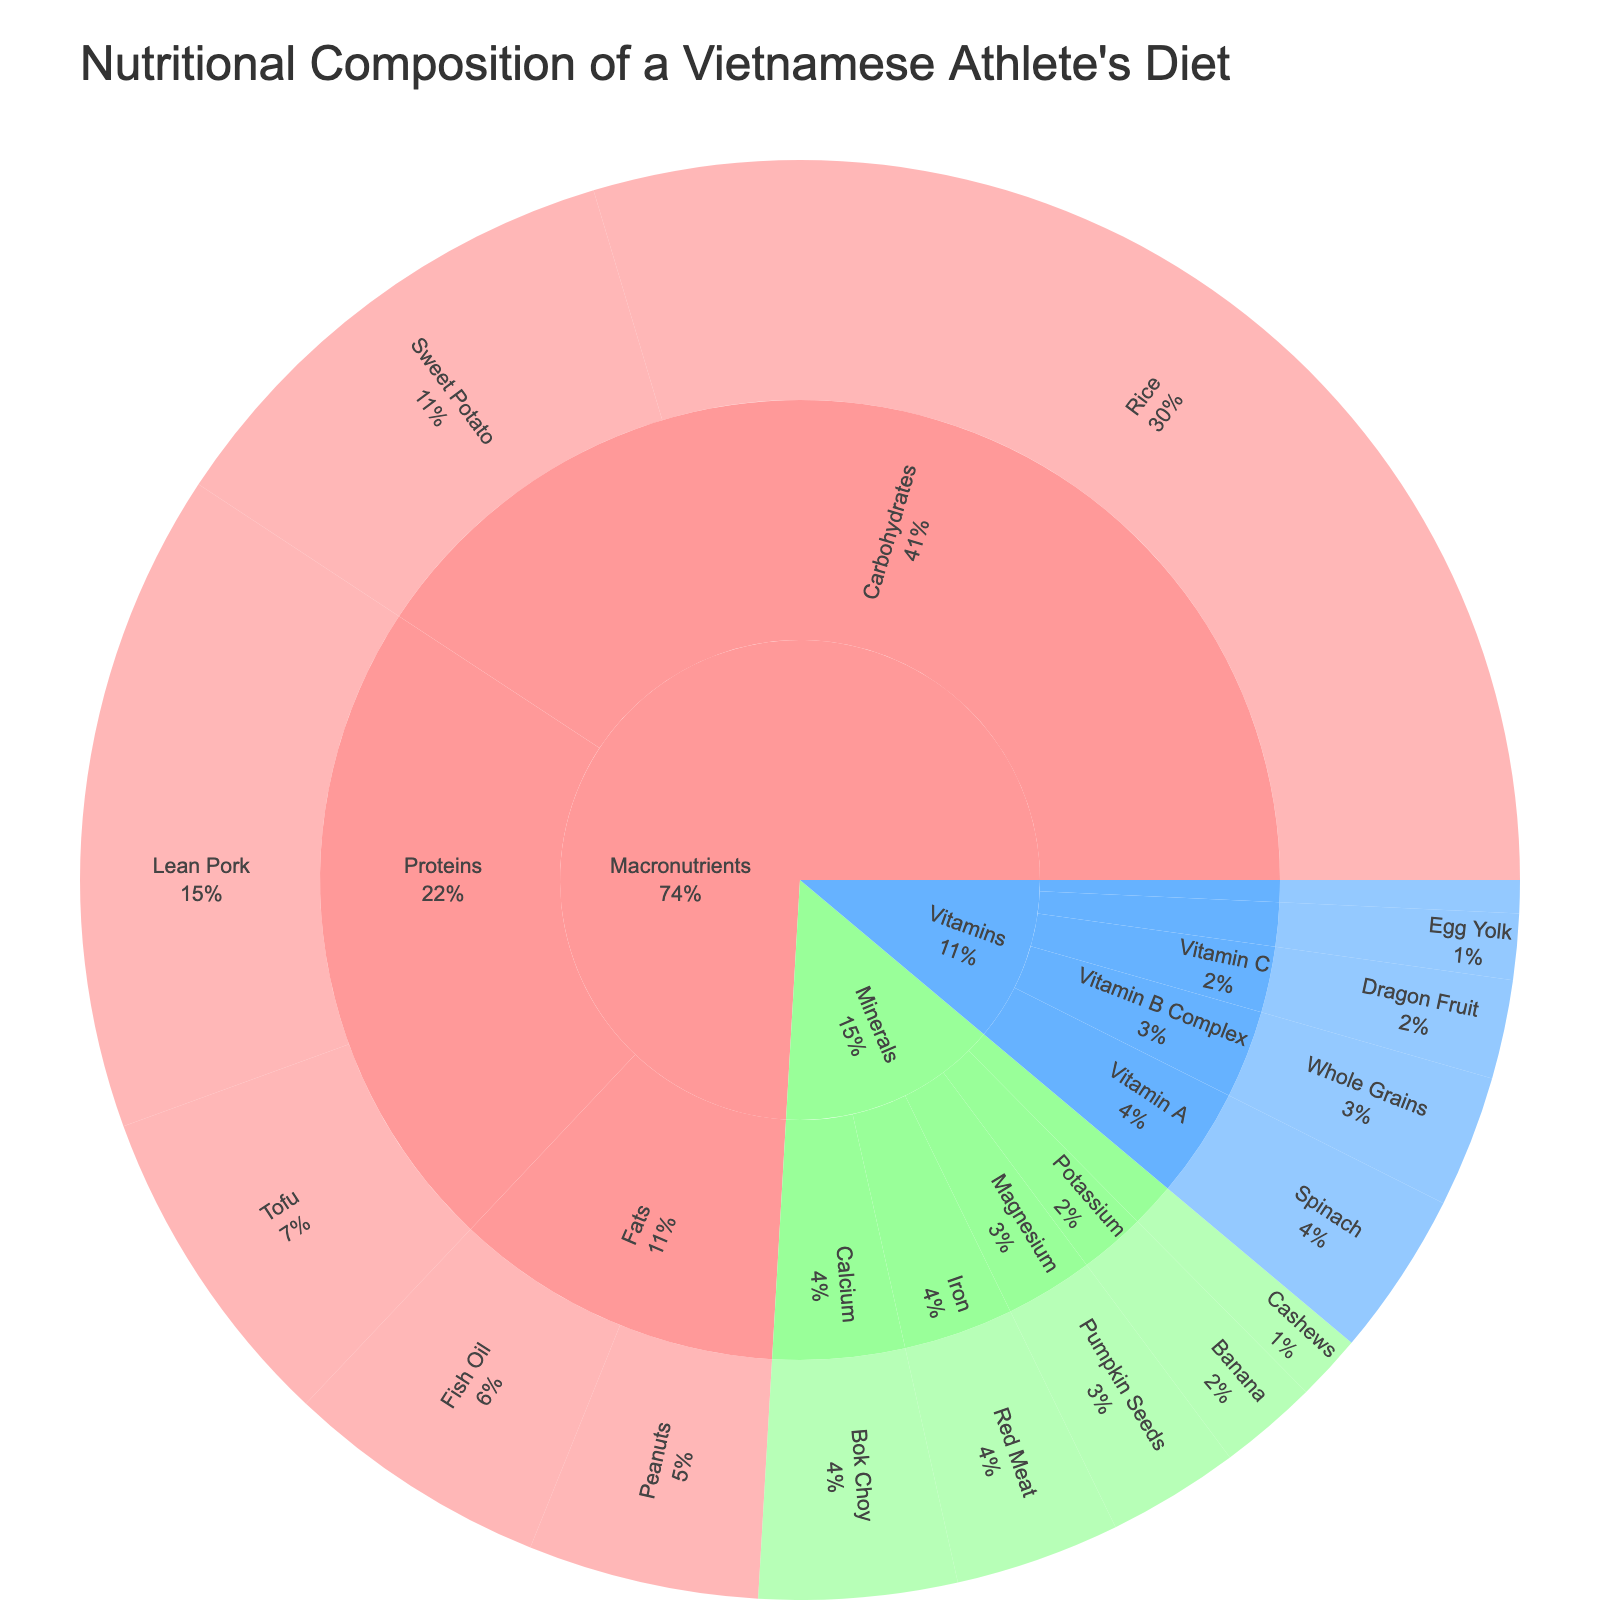What's the title of the figure? The title is located at the top of the figure and gives an overview of what the plot represents.
Answer: "Nutritional Composition of a Vietnamese Athlete's Diet" Which macronutrient item contributes the most to the diet? To find the macronutrient item with the highest value, look under the Macronutrients category and compare the values. Rice has the highest value of 40.
Answer: Rice How many vitamins are represented in the figure? Count the different subcategories under the Vitamins category to determine the number of vitamins. There are 5 vitamins: Vitamin A, Vitamin B Complex, Vitamin C, Vitamin D, and Vitamin E.
Answer: 5 What is the combined value of all fat sources in the diet? Add up the values of all items under the Fats subcategory in the Macronutrients category. Fish Oil (8) + Peanuts (7) = 15.
Answer: 15 Which mineral has the lowest representation in the diet? Compare the values of different items under the Minerals category. Zinc from Cashews has the lowest value of 2.
Answer: Zinc How does the value of protein sources compare to the value of carbohydrate sources? Add the values of Lean Pork and Tofu for proteins and Rice and Sweet Potato for carbohydrates, then compare. Proteins: 20 + 10 = 30, Carbohydrates: 40 + 15 = 55. 55 > 30, thus carbohydrates are greater.
Answer: Carbohydrates are greater What's the total nutritional value from minerals? Sum up the values of all items under the Minerals category: Calcium (6) + Iron (5) + Magnesium (4) + Potassium (3) + Zinc (2) = 20.
Answer: 20 Which vitamin has the highest value and what is it? Compare the values of items in the Vitamins category. Spinach, under Vitamin A, has the highest value of 5.
Answer: Vitamin A (Spinach) If you remove the value of tofu, what percentage of the protein subcategory remains? First, calculate the total value of proteins. Total proteins: Lean Pork (20) + Tofu (10) = 30. Removing Tofu leaves: Lean Pork (20). Percentage: (20 / 30) * 100 = 66.67%.
Answer: 66.67% Which category contributes the most to the overall diet? We need to sum the values in each category. Macronutrients: 40 + 15 + 20 + 10 + 8 + 7 = 100, Vitamins: 5 + 4 + 3 + 2 + 1 = 15, Minerals: 6 + 5 + 4 + 3 + 2 = 20. The highest sum is for Macronutrients.
Answer: Macronutrients 